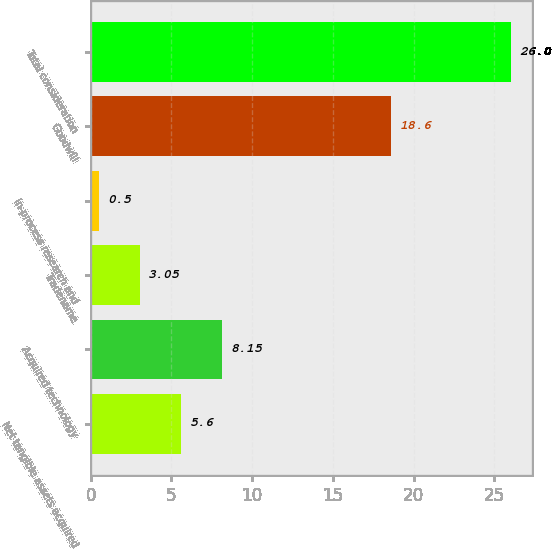Convert chart. <chart><loc_0><loc_0><loc_500><loc_500><bar_chart><fcel>Net tangible assets acquired<fcel>Acquired technology<fcel>Tradename<fcel>In-process research and<fcel>Goodwill<fcel>Total consideration<nl><fcel>5.6<fcel>8.15<fcel>3.05<fcel>0.5<fcel>18.6<fcel>26<nl></chart> 